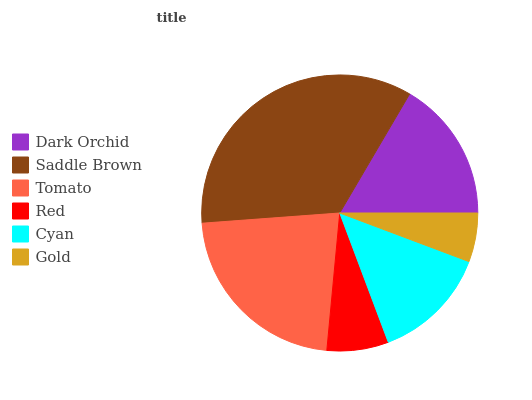Is Gold the minimum?
Answer yes or no. Yes. Is Saddle Brown the maximum?
Answer yes or no. Yes. Is Tomato the minimum?
Answer yes or no. No. Is Tomato the maximum?
Answer yes or no. No. Is Saddle Brown greater than Tomato?
Answer yes or no. Yes. Is Tomato less than Saddle Brown?
Answer yes or no. Yes. Is Tomato greater than Saddle Brown?
Answer yes or no. No. Is Saddle Brown less than Tomato?
Answer yes or no. No. Is Dark Orchid the high median?
Answer yes or no. Yes. Is Cyan the low median?
Answer yes or no. Yes. Is Tomato the high median?
Answer yes or no. No. Is Saddle Brown the low median?
Answer yes or no. No. 